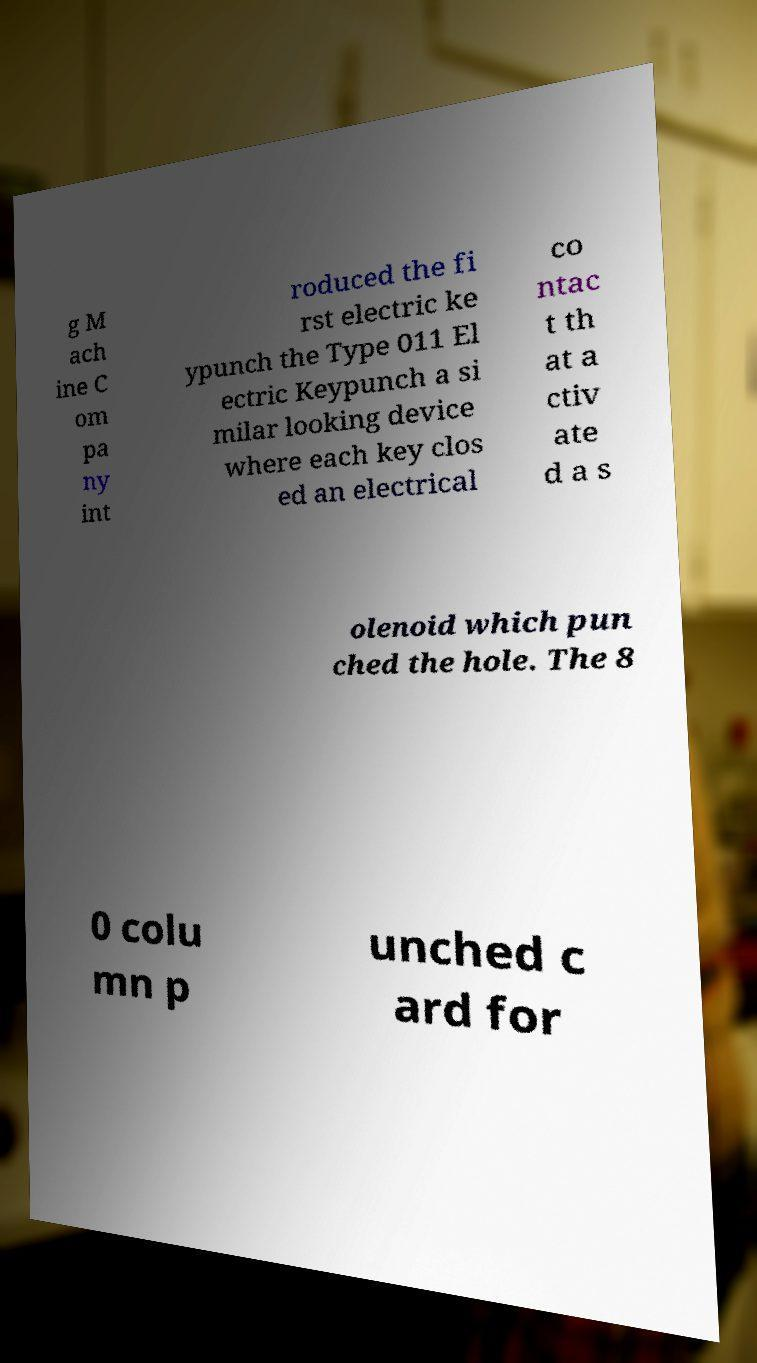For documentation purposes, I need the text within this image transcribed. Could you provide that? g M ach ine C om pa ny int roduced the fi rst electric ke ypunch the Type 011 El ectric Keypunch a si milar looking device where each key clos ed an electrical co ntac t th at a ctiv ate d a s olenoid which pun ched the hole. The 8 0 colu mn p unched c ard for 